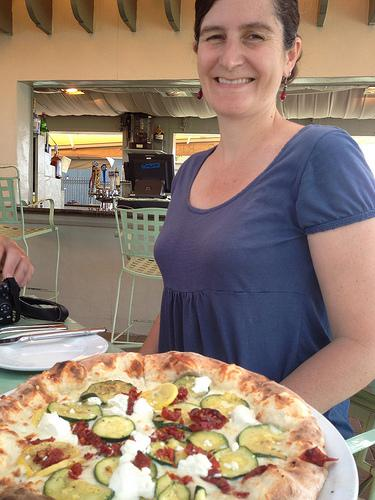Question: what is on the table?
Choices:
A. Apple pie.
B. Cake.
C. Cookie.
D. Pizza.
Answer with the letter. Answer: D Question: what is on the pizza?
Choices:
A. Pepporoni.
B. Green Peppers.
C. Black Olives.
D. Cheese.
Answer with the letter. Answer: D Question: who is in the photograph?
Choices:
A. A woman.
B. A Teacher.
C. A hairdresser.
D. A singer.
Answer with the letter. Answer: A Question: how does the woman feel?
Choices:
A. Sad.
B. Mad.
C. Exhausted.
D. Happy.
Answer with the letter. Answer: D Question: what type of shirt is the woman wearing?
Choices:
A. Halter top.
B. Short sleeve.
C. Tank top.
D. Blouse.
Answer with the letter. Answer: B Question: what race is the woman?
Choices:
A. Black.
B. Asian.
C. Hispanic.
D. White.
Answer with the letter. Answer: D 